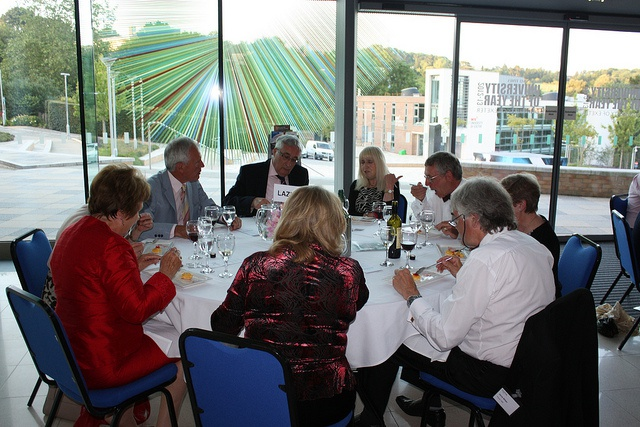Describe the objects in this image and their specific colors. I can see people in white, black, maroon, and gray tones, people in white, darkgray, black, and gray tones, dining table in white, darkgray, gray, and lightblue tones, people in white, maroon, black, darkgray, and gray tones, and chair in white, black, gray, and navy tones in this image. 